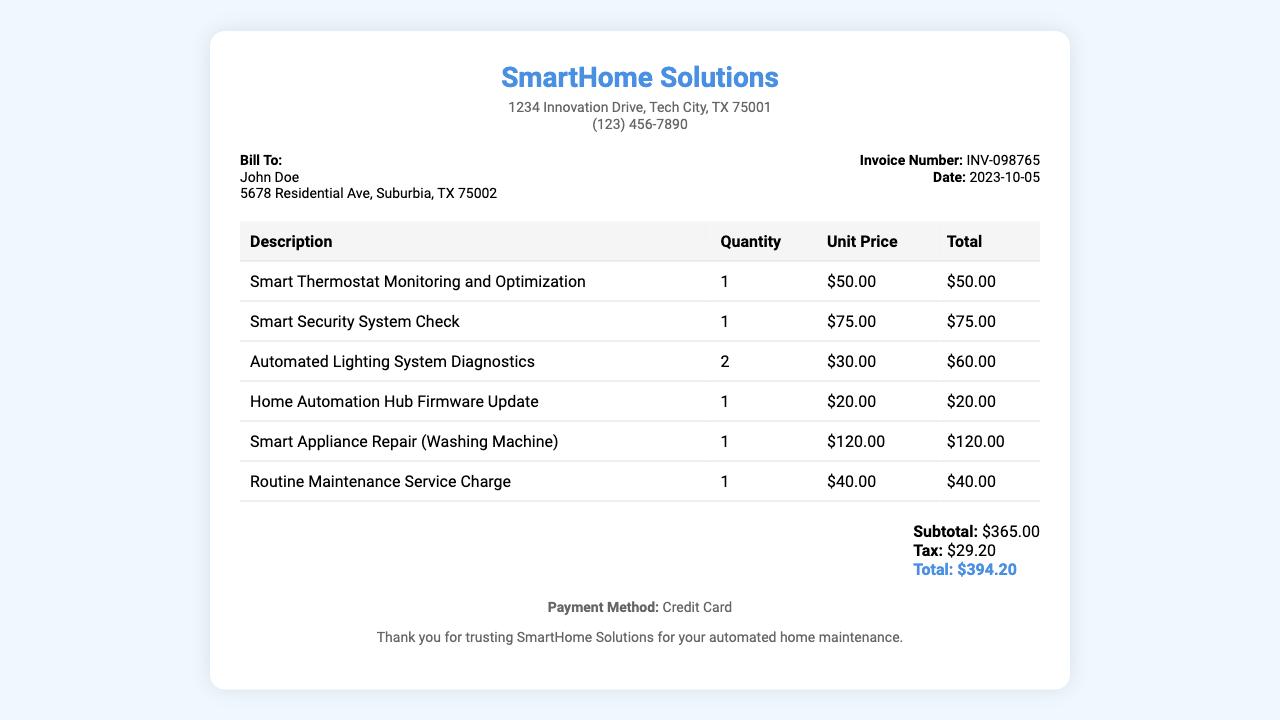What is the company name? The company name is prominently displayed at the top of the receipt.
Answer: SmartHome Solutions What is the invoice number? The invoice number is located in the invoice details section.
Answer: INV-098765 What is the date of the invoice? The date can be found in the invoice details section next to the invoice number.
Answer: 2023-10-05 How much was charged for the smart thermostat monitoring? This information is in the itemized charge section of the receipt.
Answer: $50.00 What is the subtotal amount? The subtotal is presented before the tax and total amounts in the summary section.
Answer: $365.00 How many automated lighting system diagnostics were performed? This information is found in the itemized charges where the quantity is listed.
Answer: 2 What is the total amount due? The total amount is the final value listed in the summary section.
Answer: $394.20 What is the payment method? The payment method is mentioned at the bottom of the receipt.
Answer: Credit Card What type of service was performed for the washing machine? The description for the washing machine service is listed in the itemized charges.
Answer: Smart Appliance Repair What is the tax amount? The tax amount can be found in the summary section just below the subtotal.
Answer: $29.20 